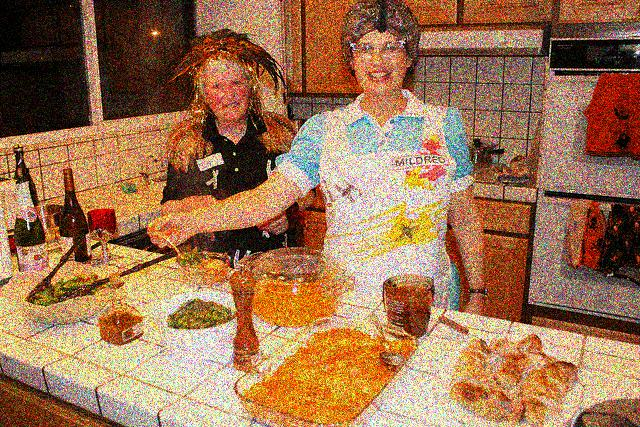Do the two women appear blurry?
A. Yes
B. No
Answer with the option's letter from the given choices directly.
 A. 